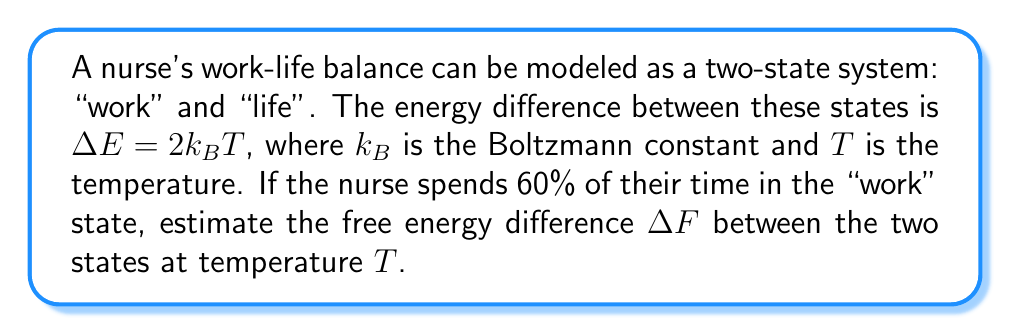Provide a solution to this math problem. To solve this problem, we'll use the principles of statistical mechanics:

1) First, let's define the partition function $Z$ for this two-state system:

   $$Z = e^{-\beta E_{\text{work}}} + e^{-\beta E_{\text{life}}}$$

   where $\beta = \frac{1}{k_BT}$

2) We're given that $\Delta E = E_{\text{work}} - E_{\text{life}} = 2k_BT$. Let's set $E_{\text{life}} = 0$ for simplicity. Then:

   $$E_{\text{work}} = 2k_BT$$

3) Now we can write the partition function as:

   $$Z = e^{-\beta(2k_BT)} + e^{-\beta(0)} = e^{-2} + 1$$

4) The probability of being in the work state is given by:

   $$P_{\text{work}} = \frac{e^{-\beta E_{\text{work}}}}{Z} = \frac{e^{-2}}{e^{-2} + 1} = 0.6$$

5) We can use this to find the free energy difference:

   $$\Delta F = -k_BT \ln\left(\frac{P_{\text{work}}}{P_{\text{life}}}\right)$$

6) We know $P_{\text{work}} = 0.6$, so $P_{\text{life}} = 1 - 0.6 = 0.4$

7) Substituting these values:

   $$\Delta F = -k_BT \ln\left(\frac{0.6}{0.4}\right) = -k_BT \ln(1.5)$$

8) We can simplify this further:

   $$\Delta F = -k_BT(0.405) \approx -0.405k_BT$$
Answer: $\Delta F \approx -0.405k_BT$ 